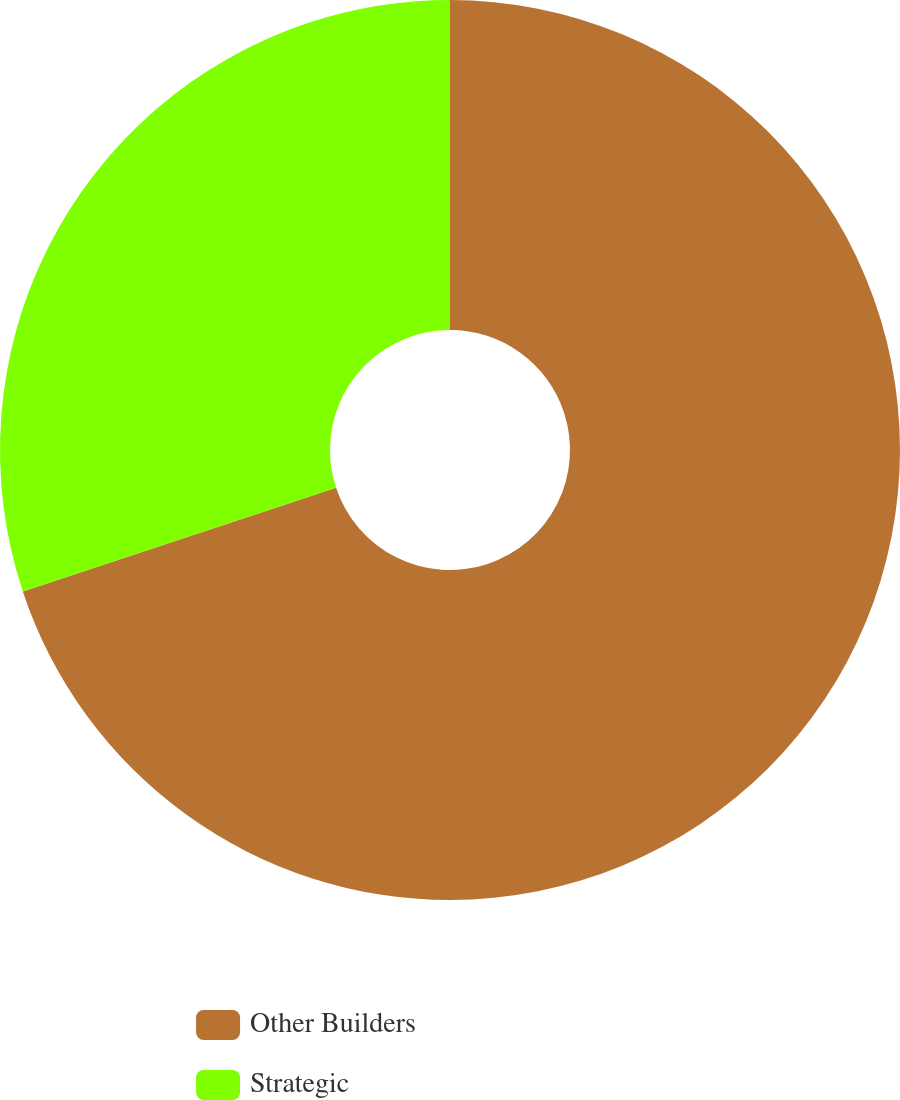<chart> <loc_0><loc_0><loc_500><loc_500><pie_chart><fcel>Other Builders<fcel>Strategic<nl><fcel>69.91%<fcel>30.09%<nl></chart> 